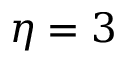Convert formula to latex. <formula><loc_0><loc_0><loc_500><loc_500>\eta = 3</formula> 